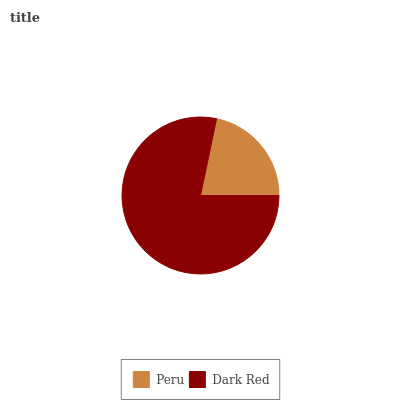Is Peru the minimum?
Answer yes or no. Yes. Is Dark Red the maximum?
Answer yes or no. Yes. Is Dark Red the minimum?
Answer yes or no. No. Is Dark Red greater than Peru?
Answer yes or no. Yes. Is Peru less than Dark Red?
Answer yes or no. Yes. Is Peru greater than Dark Red?
Answer yes or no. No. Is Dark Red less than Peru?
Answer yes or no. No. Is Dark Red the high median?
Answer yes or no. Yes. Is Peru the low median?
Answer yes or no. Yes. Is Peru the high median?
Answer yes or no. No. Is Dark Red the low median?
Answer yes or no. No. 